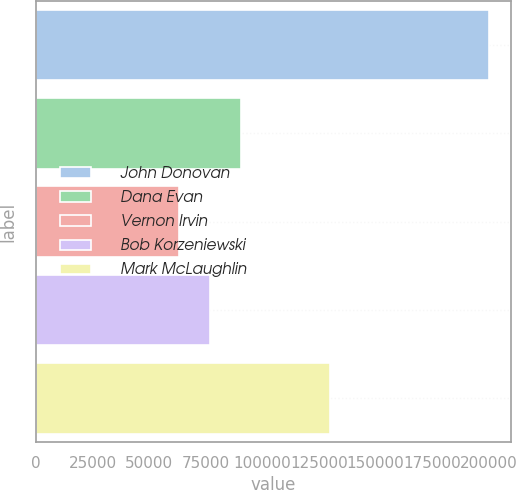<chart> <loc_0><loc_0><loc_500><loc_500><bar_chart><fcel>John Donovan<fcel>Dana Evan<fcel>Vernon Irvin<fcel>Bob Korzeniewski<fcel>Mark McLaughlin<nl><fcel>200000<fcel>90400<fcel>63000<fcel>76700<fcel>130000<nl></chart> 